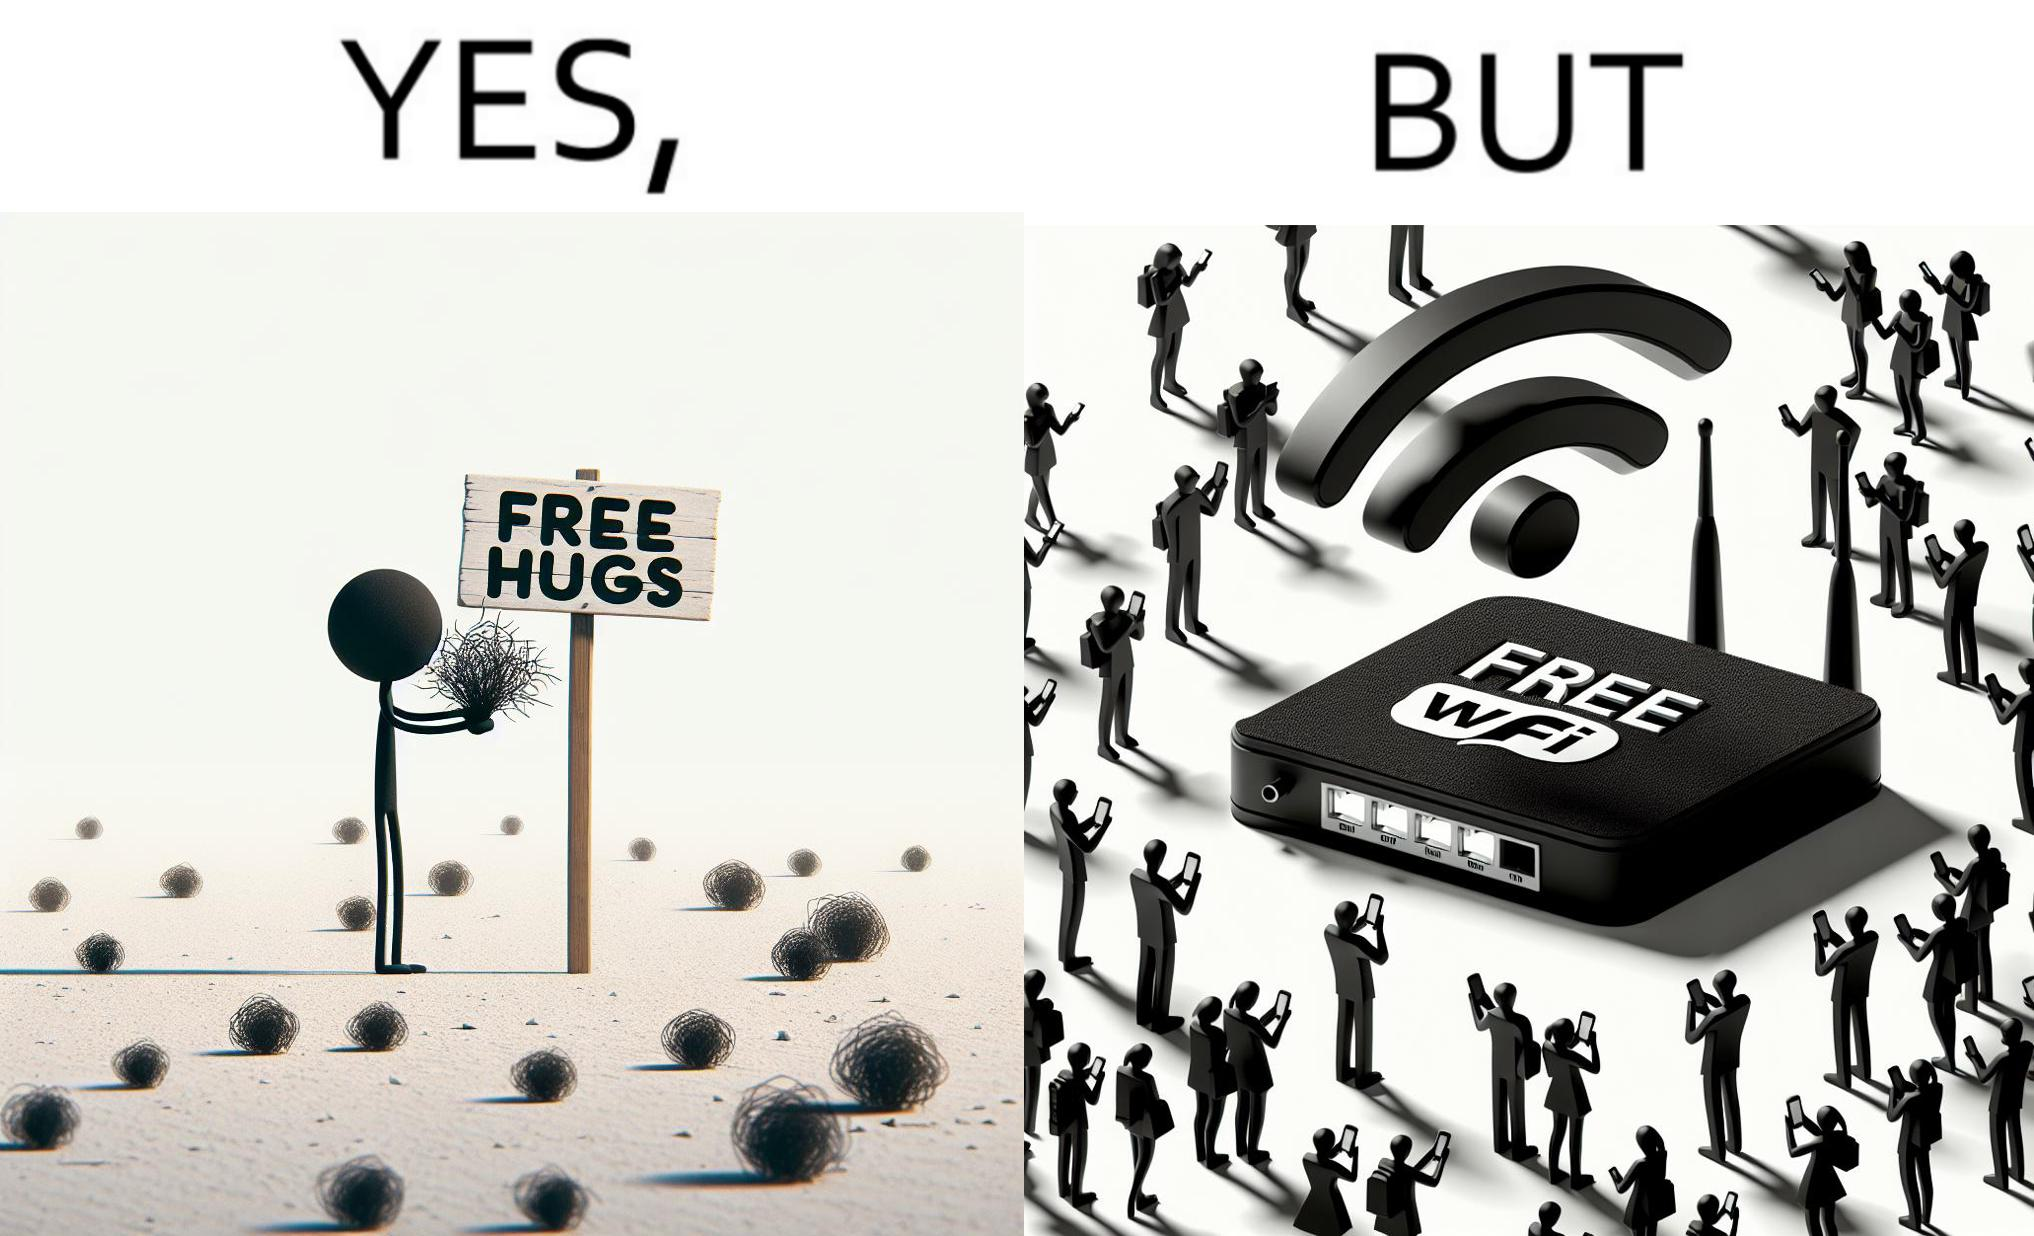Explain the humor or irony in this image. This image is ironical, as a person holding up a "Free Hugs" sign is standing alone, while an inanimate Wi-fi Router giving "Free Wifi" is surrounded people trying to connect to it. This shows a growing lack of empathy in our society, while showing our increasing dependence on the digital devices in a virtual world. 